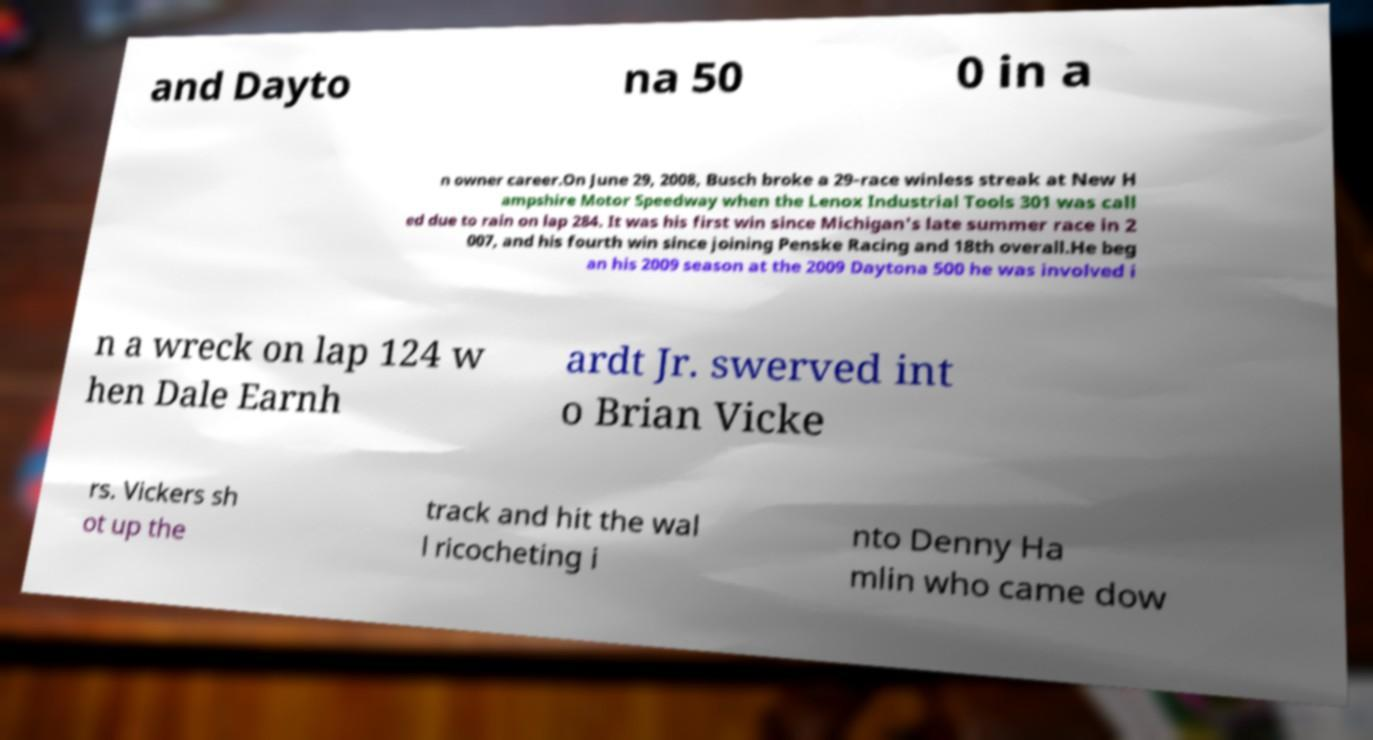Can you accurately transcribe the text from the provided image for me? and Dayto na 50 0 in a n owner career.On June 29, 2008, Busch broke a 29-race winless streak at New H ampshire Motor Speedway when the Lenox Industrial Tools 301 was call ed due to rain on lap 284. It was his first win since Michigan's late summer race in 2 007, and his fourth win since joining Penske Racing and 18th overall.He beg an his 2009 season at the 2009 Daytona 500 he was involved i n a wreck on lap 124 w hen Dale Earnh ardt Jr. swerved int o Brian Vicke rs. Vickers sh ot up the track and hit the wal l ricocheting i nto Denny Ha mlin who came dow 